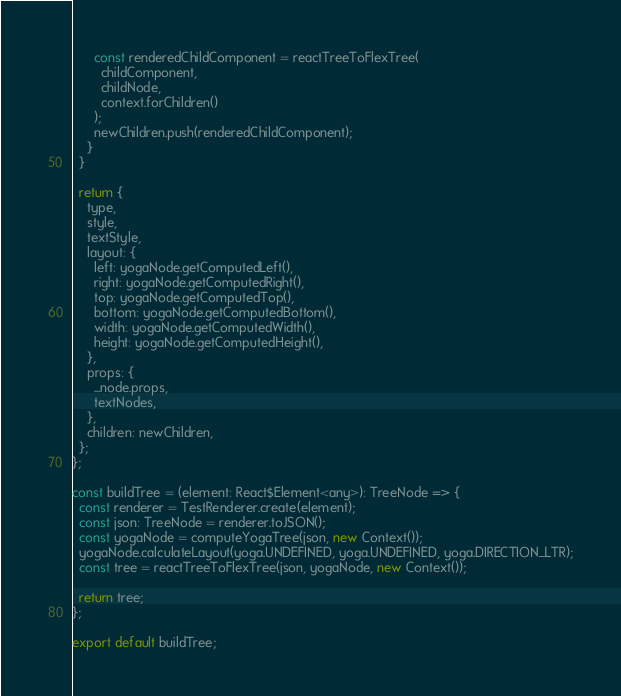Convert code to text. <code><loc_0><loc_0><loc_500><loc_500><_JavaScript_>
      const renderedChildComponent = reactTreeToFlexTree(
        childComponent,
        childNode,
        context.forChildren()
      );
      newChildren.push(renderedChildComponent);
    }
  }

  return {
    type,
    style,
    textStyle,
    layout: {
      left: yogaNode.getComputedLeft(),
      right: yogaNode.getComputedRight(),
      top: yogaNode.getComputedTop(),
      bottom: yogaNode.getComputedBottom(),
      width: yogaNode.getComputedWidth(),
      height: yogaNode.getComputedHeight(),
    },
    props: {
      ...node.props,
      textNodes,
    },
    children: newChildren,
  };
};

const buildTree = (element: React$Element<any>): TreeNode => {
  const renderer = TestRenderer.create(element);
  const json: TreeNode = renderer.toJSON();
  const yogaNode = computeYogaTree(json, new Context());
  yogaNode.calculateLayout(yoga.UNDEFINED, yoga.UNDEFINED, yoga.DIRECTION_LTR);
  const tree = reactTreeToFlexTree(json, yogaNode, new Context());

  return tree;
};

export default buildTree;
</code> 